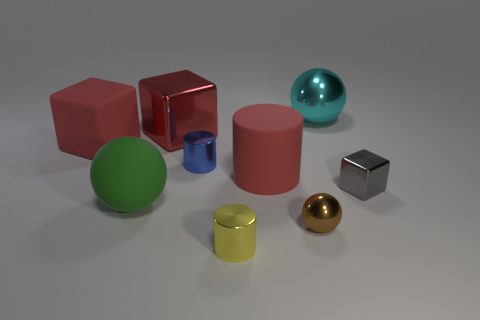What number of metallic objects are there?
Offer a very short reply. 6. There is a big red cube to the right of the large matte object that is in front of the gray shiny thing; what is it made of?
Keep it short and to the point. Metal. The tiny block that is the same material as the tiny brown object is what color?
Offer a very short reply. Gray. What is the shape of the big shiny object that is the same color as the big rubber block?
Keep it short and to the point. Cube. There is a matte object in front of the gray metal cube; is its size the same as the shiny cylinder that is to the left of the yellow metallic cylinder?
Give a very brief answer. No. What number of cubes are either big gray things or tiny blue objects?
Ensure brevity in your answer.  0. Is the material of the blue cylinder to the right of the large green sphere the same as the gray object?
Your answer should be very brief. Yes. How many other objects are there of the same size as the rubber ball?
Ensure brevity in your answer.  4. What number of large things are blue things or yellow things?
Offer a terse response. 0. Is the color of the matte block the same as the big rubber cylinder?
Your answer should be compact. Yes. 